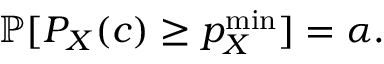Convert formula to latex. <formula><loc_0><loc_0><loc_500><loc_500>\mathbb { P } [ P _ { X } ( c ) \geq p _ { X } ^ { \min } ] = \alpha .</formula> 